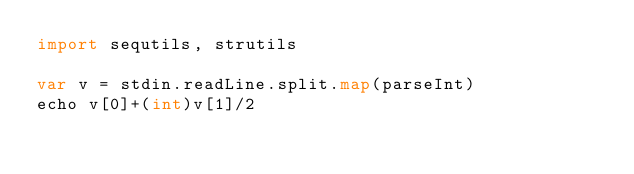Convert code to text. <code><loc_0><loc_0><loc_500><loc_500><_Nim_>import sequtils, strutils

var v = stdin.readLine.split.map(parseInt)
echo v[0]+(int)v[1]/2
</code> 